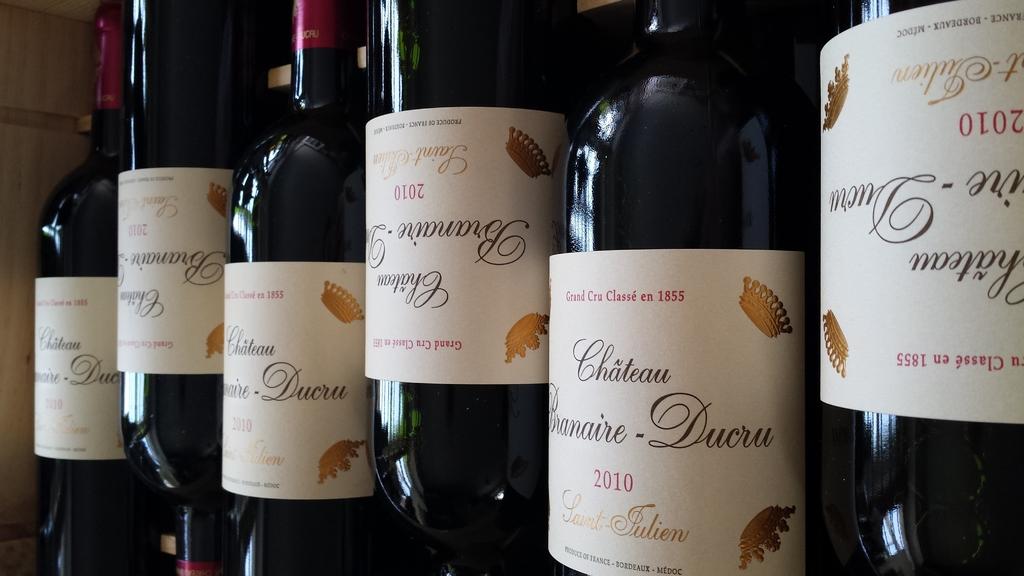What year are these bottles?
Provide a short and direct response. 2010. What is this brand of wine?
Your answer should be compact. Unanswerable. 